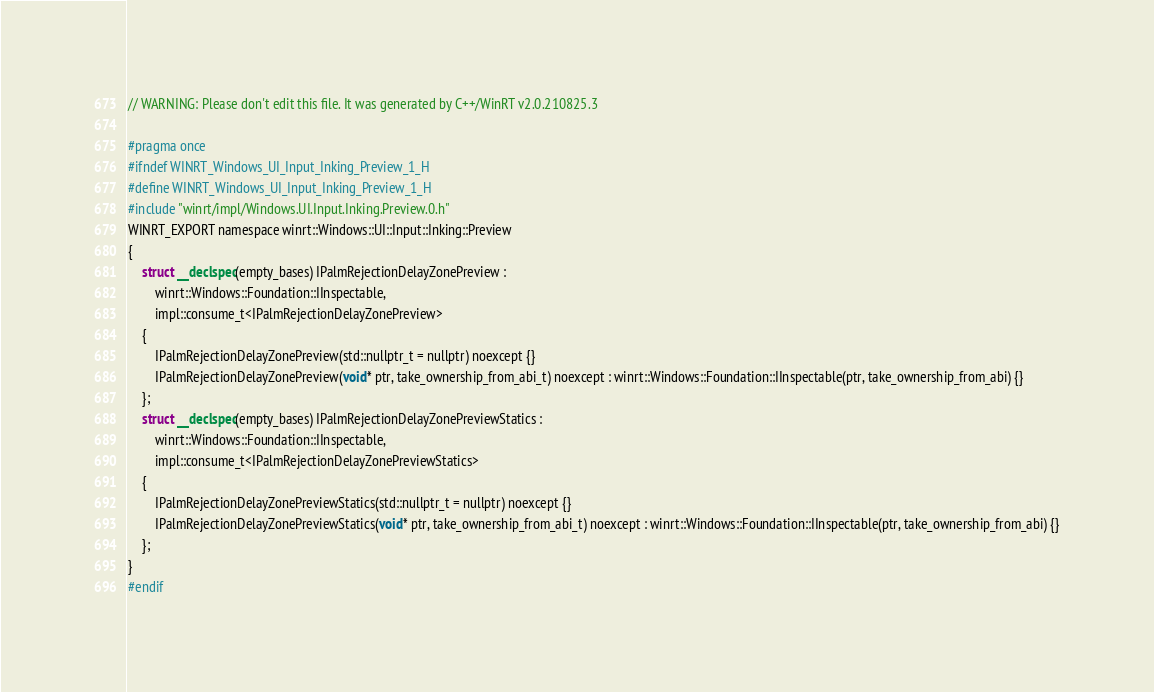Convert code to text. <code><loc_0><loc_0><loc_500><loc_500><_C_>// WARNING: Please don't edit this file. It was generated by C++/WinRT v2.0.210825.3

#pragma once
#ifndef WINRT_Windows_UI_Input_Inking_Preview_1_H
#define WINRT_Windows_UI_Input_Inking_Preview_1_H
#include "winrt/impl/Windows.UI.Input.Inking.Preview.0.h"
WINRT_EXPORT namespace winrt::Windows::UI::Input::Inking::Preview
{
    struct __declspec(empty_bases) IPalmRejectionDelayZonePreview :
        winrt::Windows::Foundation::IInspectable,
        impl::consume_t<IPalmRejectionDelayZonePreview>
    {
        IPalmRejectionDelayZonePreview(std::nullptr_t = nullptr) noexcept {}
        IPalmRejectionDelayZonePreview(void* ptr, take_ownership_from_abi_t) noexcept : winrt::Windows::Foundation::IInspectable(ptr, take_ownership_from_abi) {}
    };
    struct __declspec(empty_bases) IPalmRejectionDelayZonePreviewStatics :
        winrt::Windows::Foundation::IInspectable,
        impl::consume_t<IPalmRejectionDelayZonePreviewStatics>
    {
        IPalmRejectionDelayZonePreviewStatics(std::nullptr_t = nullptr) noexcept {}
        IPalmRejectionDelayZonePreviewStatics(void* ptr, take_ownership_from_abi_t) noexcept : winrt::Windows::Foundation::IInspectable(ptr, take_ownership_from_abi) {}
    };
}
#endif
</code> 